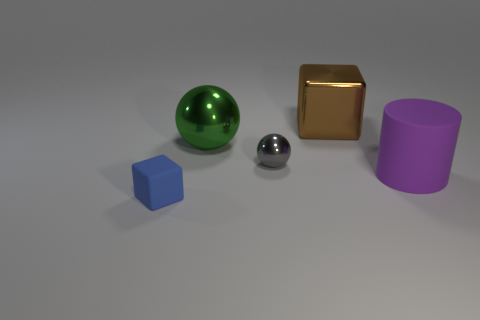Imagine these shapes were part of a children's toy set. How would you describe the educational value of these items? These geometric shapes could be a valuable educational tool for children. They help kids learn about different geometric forms and understand spatial relationships. The distinct colors enhance sensory development and can be used to teach color recognition. Arranging and fitting these shapes could also improve fine motor skills and hand-eye coordination, while encouraging problem-solving and creativity as children discover ways to interact with the set. 